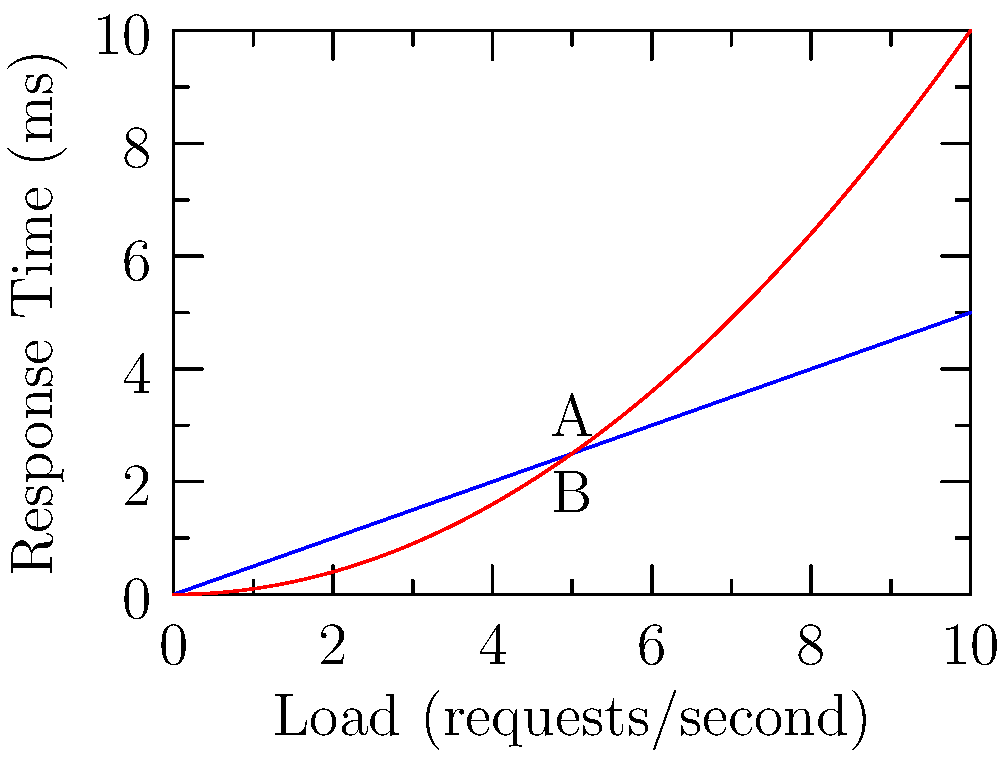Given the load vs. response time graph for two different software systems, which system (A or B) demonstrates better scalability, and why? To analyze the scalability of the two systems, we need to examine how their response times change as the load increases:

1. System A (blue line):
   - Shows a linear relationship between load and response time.
   - As load increases, response time increases proportionally.
   - The slope of the line is constant, indicating a predictable performance degradation.

2. System B (red line):
   - Displays a non-linear (quadratic) relationship between load and response time.
   - As load increases, response time grows exponentially.
   - The curve becomes steeper at higher loads, indicating rapid performance degradation.

3. Scalability comparison:
   - At lower loads, System B performs better (lower response times).
   - As load increases, System A maintains a more consistent performance.
   - At higher loads, System A outperforms System B significantly.

4. Scalability analysis:
   - System A's linear scaling allows for more predictable performance under increasing load.
   - System B's non-linear scaling leads to unpredictable and rapidly degrading performance at higher loads.

5. Conclusion:
   System A demonstrates better scalability because its performance degrades linearly and predictably as load increases, allowing for easier capacity planning and more stable performance at higher loads.
Answer: System A, due to its linear and predictable performance degradation under increasing load. 